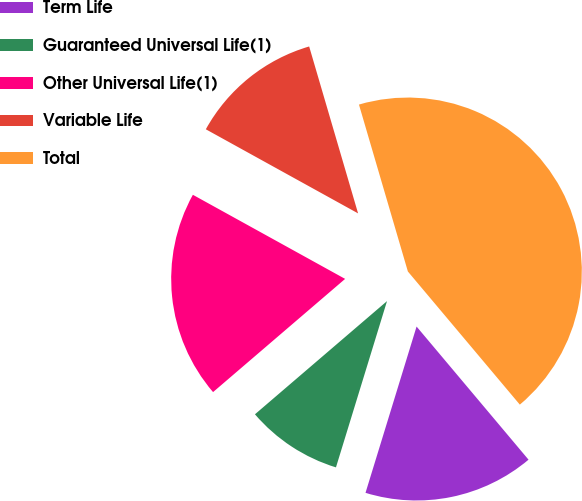Convert chart to OTSL. <chart><loc_0><loc_0><loc_500><loc_500><pie_chart><fcel>Term Life<fcel>Guaranteed Universal Life(1)<fcel>Other Universal Life(1)<fcel>Variable Life<fcel>Total<nl><fcel>15.87%<fcel>8.98%<fcel>19.31%<fcel>12.43%<fcel>43.41%<nl></chart> 